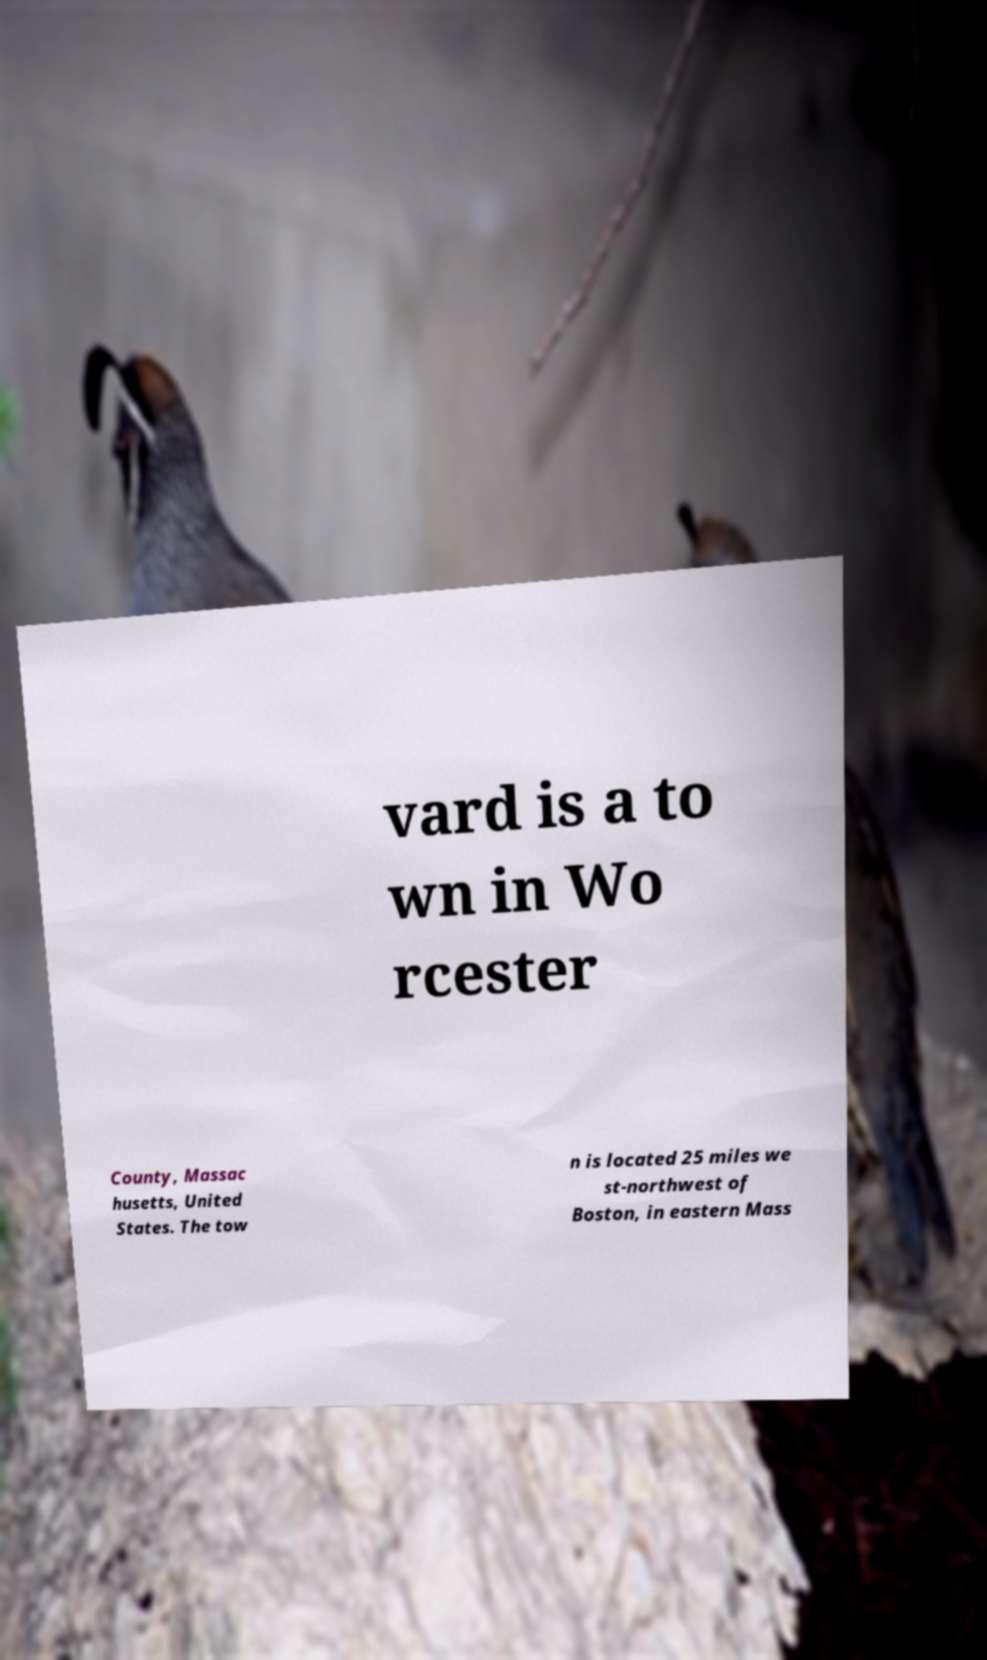Could you assist in decoding the text presented in this image and type it out clearly? vard is a to wn in Wo rcester County, Massac husetts, United States. The tow n is located 25 miles we st-northwest of Boston, in eastern Mass 